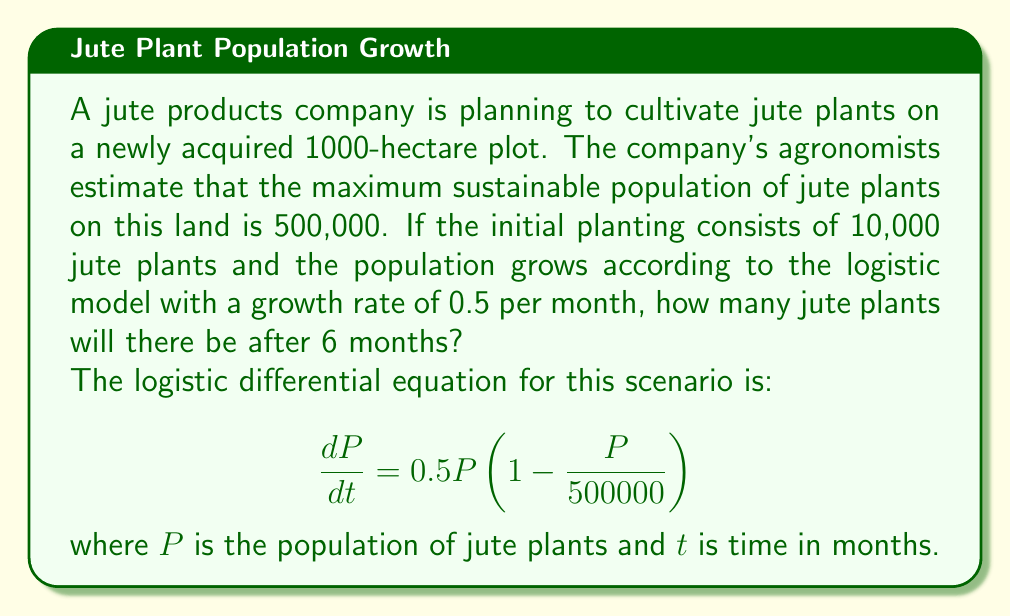Can you answer this question? To solve this problem, we need to use the solution to the logistic differential equation:

$$P(t) = \frac{K}{1 + \left(\frac{K}{P_0} - 1\right)e^{-rt}}$$

Where:
- $K$ is the carrying capacity (maximum sustainable population)
- $P_0$ is the initial population
- $r$ is the growth rate
- $t$ is the time

Given:
- $K = 500,000$
- $P_0 = 10,000$
- $r = 0.5$ per month
- $t = 6$ months

Let's substitute these values into the equation:

$$P(6) = \frac{500000}{1 + \left(\frac{500000}{10000} - 1\right)e^{-0.5 \cdot 6}}$$

$$= \frac{500000}{1 + (49)e^{-3}}$$

Now, let's calculate this step by step:

1. Calculate $e^{-3}$:
   $e^{-3} \approx 0.0498$

2. Multiply by 49:
   $49 \cdot 0.0498 \approx 2.4402$

3. Add 1 to the result:
   $1 + 2.4402 = 3.4402$

4. Divide 500000 by this result:
   $\frac{500000}{3.4402} \approx 145,340$

Therefore, after 6 months, there will be approximately 145,340 jute plants.
Answer: 145,340 jute plants (rounded to the nearest whole plant) 